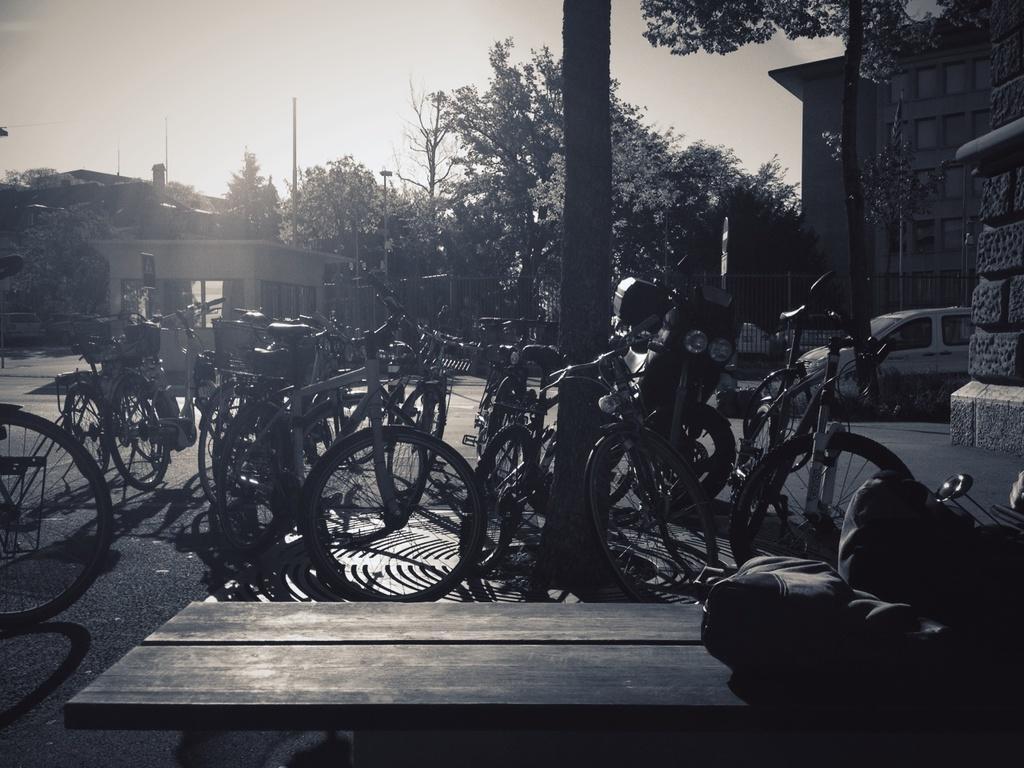Could you give a brief overview of what you see in this image? In this image in front there is a wooden table. On top of it there are a few objects. Behind the table there are cycles on the road. On the right side of the image there is a car. In the background of the image there are buildings, trees, poles and sky. 